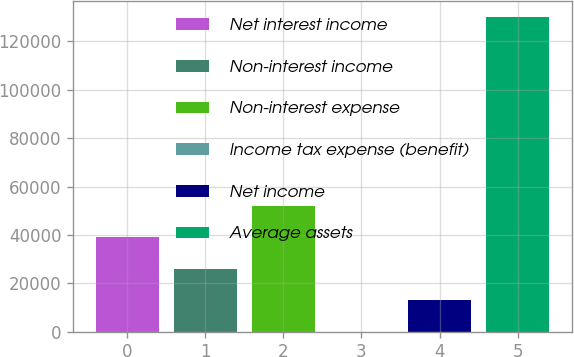Convert chart. <chart><loc_0><loc_0><loc_500><loc_500><bar_chart><fcel>Net interest income<fcel>Non-interest income<fcel>Non-interest expense<fcel>Income tax expense (benefit)<fcel>Net income<fcel>Average assets<nl><fcel>39014.3<fcel>26020.2<fcel>52008.4<fcel>32<fcel>13026.1<fcel>129973<nl></chart> 